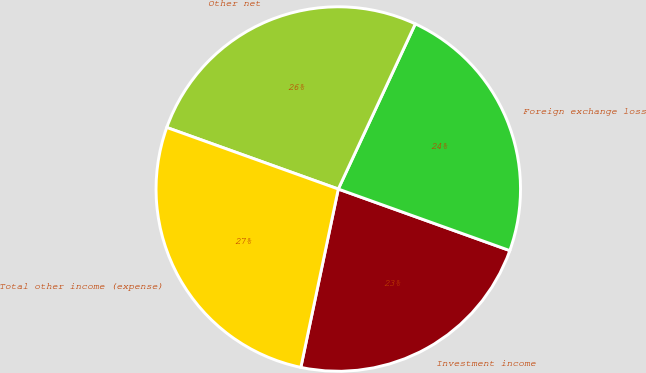Convert chart to OTSL. <chart><loc_0><loc_0><loc_500><loc_500><pie_chart><fcel>Investment income<fcel>Foreign exchange loss<fcel>Other net<fcel>Total other income (expense)<nl><fcel>22.81%<fcel>23.54%<fcel>26.46%<fcel>27.19%<nl></chart> 